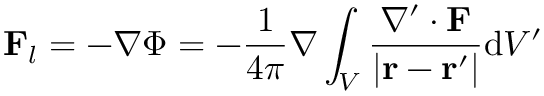Convert formula to latex. <formula><loc_0><loc_0><loc_500><loc_500>F _ { l } = - \nabla \Phi = - { \frac { 1 } { 4 \pi } } \nabla \int _ { V } { \frac { \nabla ^ { \prime } \cdot F } { \left | r - r ^ { \prime } \right | } } d V ^ { \prime }</formula> 